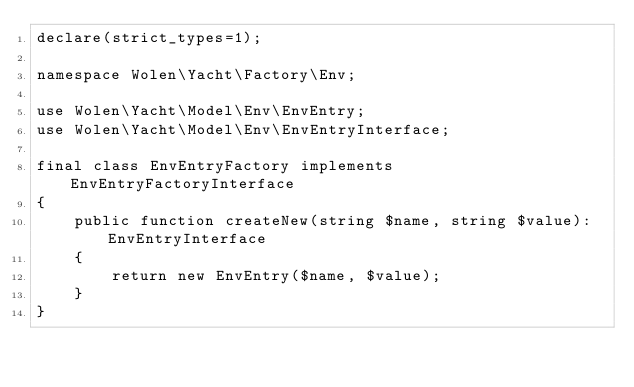<code> <loc_0><loc_0><loc_500><loc_500><_PHP_>declare(strict_types=1);

namespace Wolen\Yacht\Factory\Env;

use Wolen\Yacht\Model\Env\EnvEntry;
use Wolen\Yacht\Model\Env\EnvEntryInterface;

final class EnvEntryFactory implements EnvEntryFactoryInterface
{
    public function createNew(string $name, string $value): EnvEntryInterface
    {
        return new EnvEntry($name, $value);
    }
}
</code> 